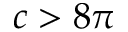Convert formula to latex. <formula><loc_0><loc_0><loc_500><loc_500>c > 8 \pi</formula> 